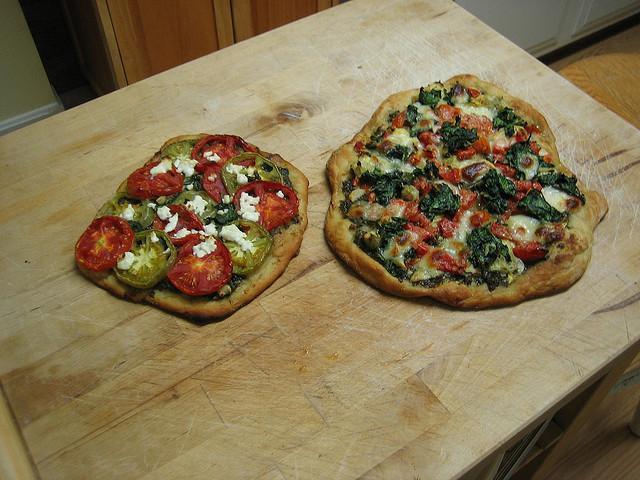What are the green vegetables next to the red tomatoes on the left-side pizza?
From the following set of four choices, select the accurate answer to respond to the question.
Options: Snap peas, jalapenos, green tomatoes, broccoli. Green tomatoes. 